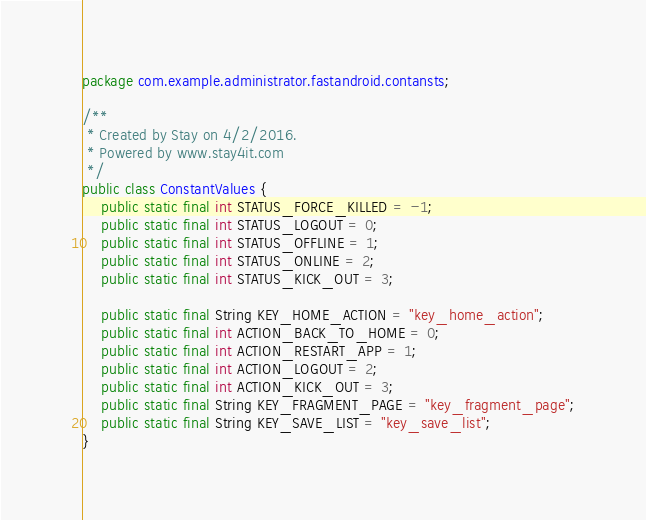<code> <loc_0><loc_0><loc_500><loc_500><_Java_>package com.example.administrator.fastandroid.contansts;

/**
 * Created by Stay on 4/2/2016.
 * Powered by www.stay4it.com
 */
public class ConstantValues {
    public static final int STATUS_FORCE_KILLED = -1;
    public static final int STATUS_LOGOUT = 0;
    public static final int STATUS_OFFLINE = 1;
    public static final int STATUS_ONLINE = 2;
    public static final int STATUS_KICK_OUT = 3;

    public static final String KEY_HOME_ACTION = "key_home_action";
    public static final int ACTION_BACK_TO_HOME = 0;
    public static final int ACTION_RESTART_APP = 1;
    public static final int ACTION_LOGOUT = 2;
    public static final int ACTION_KICK_OUT = 3;
    public static final String KEY_FRAGMENT_PAGE = "key_fragment_page";
    public static final String KEY_SAVE_LIST = "key_save_list";
}
</code> 